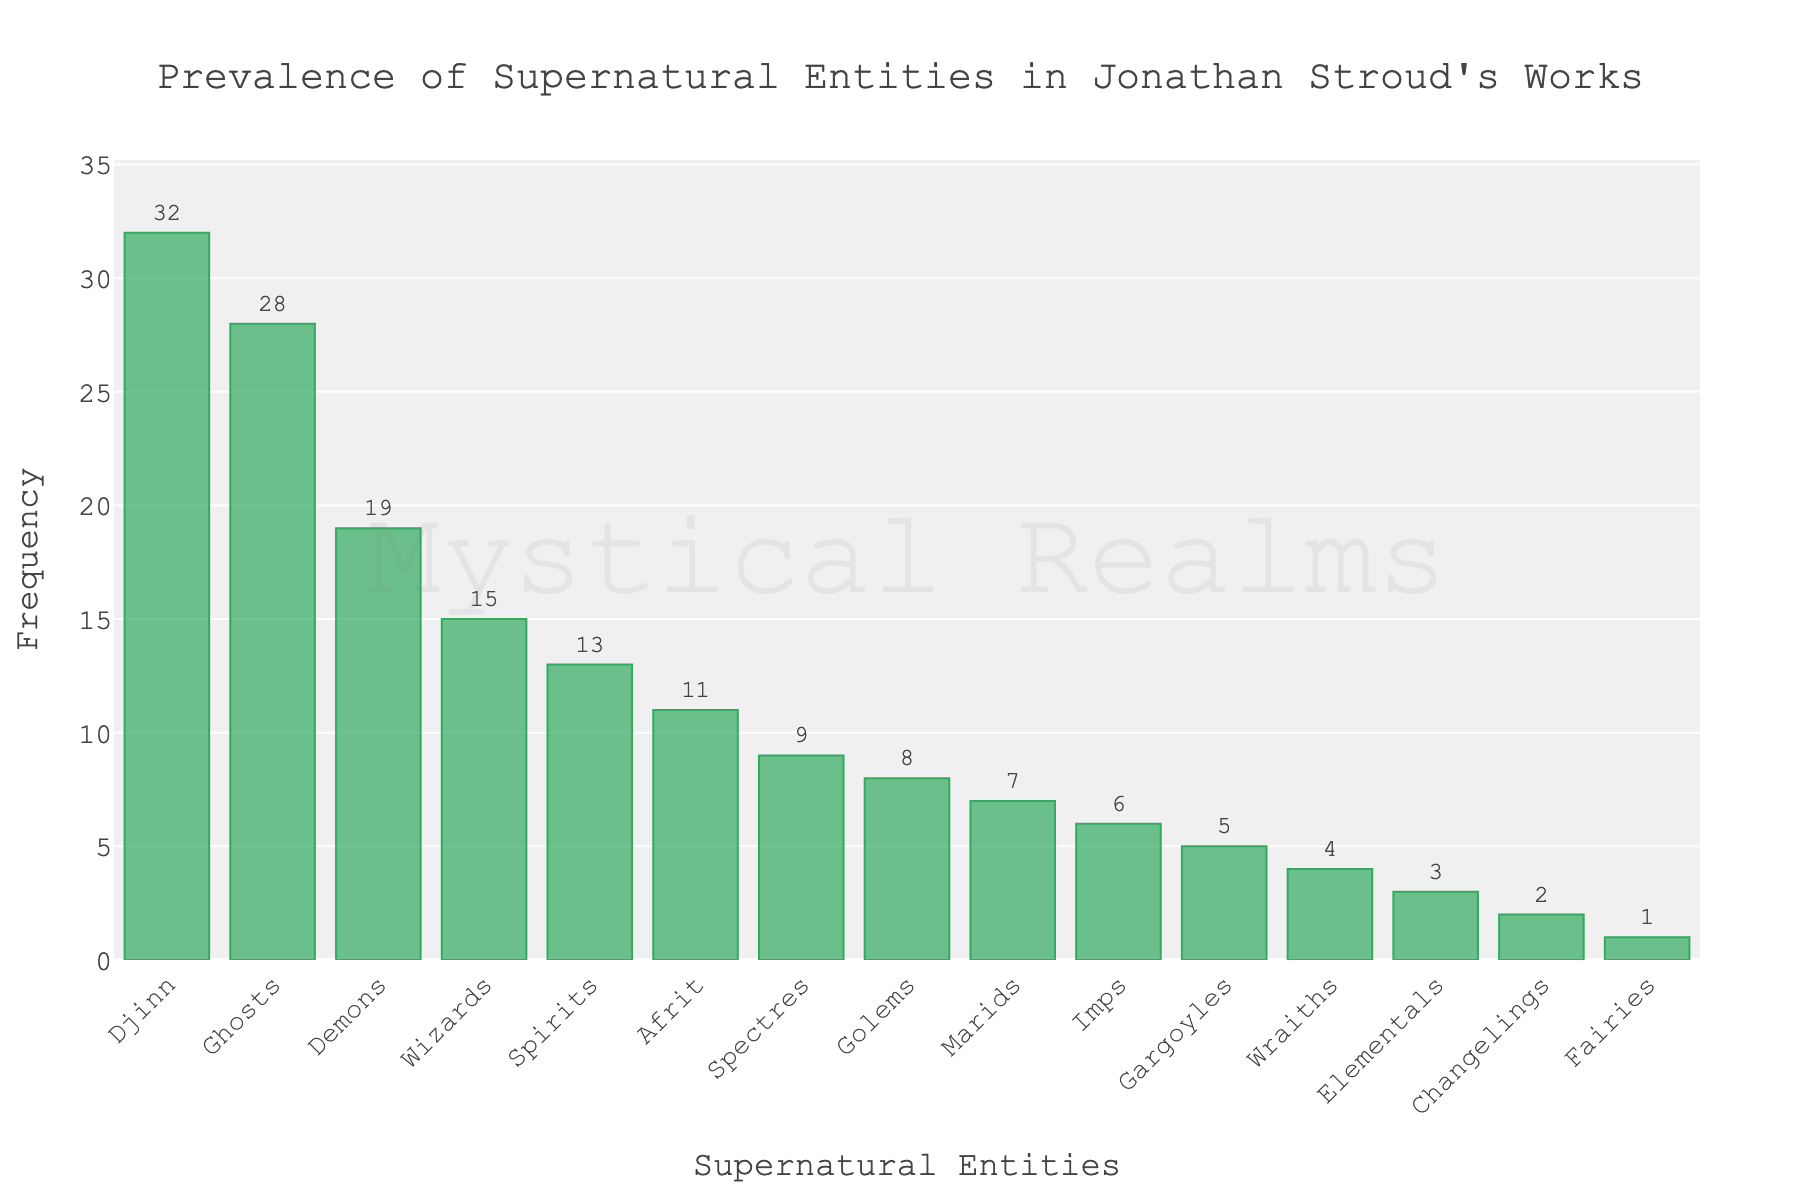what is the total frequency of all the entities combined? To find the total frequency, sum the frequencies of all entities listed in the bar chart. Adding them together: 32 (Djinn) + 28 (Ghosts) + 19 (Demons) + 15 (Wizards) + 8 (Golems) + 13 (Spirits) + 6 (Imps) + 11 (Afrit) + 7 (Marids) + 5 (Gargoyles) + 9 (Spectres) + 4 (Wraiths) + 3 (Elementals) + 2 (Changelings) + 1 (Fairies) = 163
Answer: 163 Which supernatural entity is the least prevalent in Jonathan Stroud's works? To determine the least prevalent entity, look for the entity with the smallest bar. The smallest bar corresponds to Fairies with a frequency of 1.
Answer: Fairies How many more Djinn are there compared to Wraiths in the works of Jonathan Stroud? Find the frequency of Djinn and Wraiths from the chart. Djinn appear 32 times, and Wraiths appear 4 times. Subtract the frequency of Wraiths from Djinn: 32 - 4 = 28
Answer: 28 Which entities are more prevalent than Wizards but less prevalent than Djinn? First, find the frequency of Wizards (15) and Djinn (32). Look for entities with frequencies between 15 and 32. They are Ghosts (28) and Demons (19).
Answer: Ghosts, Demons What is the ratio of the frequency of Djinn to the Frequency of Golems? The frequency of Djinn is 32 and the frequency of Golems is 8. To find the ratio, divide 32 by 8: 32 / 8 = 4. Hence, the ratio is 4:1
Answer: 4:1 Identify the entity with approximately double the occurrences of Imps. The frequency of Imps is 6. To find the entity with approximately double this value, look for a frequency close to 12. The entity with a frequency near this value is Spirits with a frequency of 13.
Answer: Spirits Which entities are less prevalent than Afrits and more prevalent than Golems? Find the frequencies for Afrit (11) and Golems (8). Entities with frequencies between 8 and 11 are Marids (7), Spectres (9), and Spirits (13). Spirits exceed the range, leaving Spectres.
Answer: Spectres What is the average frequency of Djinn, Ghosts, and Demons? Add the frequencies of Djinn (32), Ghosts (28), and Demons (19), then divide by the number of entities. (32 + 28 + 19) / 3 = 79 / 3 ≈ 26.33
Answer: Approximately 26.33 Which two entities combined have the same frequency as Ghosts? To match the frequency of Ghosts (28), find two entities whose frequencies sum to 28: Wizards (15) and Spirits (13). 15 + 13 = 28.
Answer: Wizards and Spirits Which entity has a frequency closest to the median frequency of all entities? To find the median, list the frequencies in ascending order: 1, 2, 3, 4, 5, 6, 7, 8, 9, 11, 13, 15, 19, 28, 32. The median is the middle value (8th in this sorted list), which is 9. The entity with a frequency closest to 9 is Spectres.
Answer: Spectres 